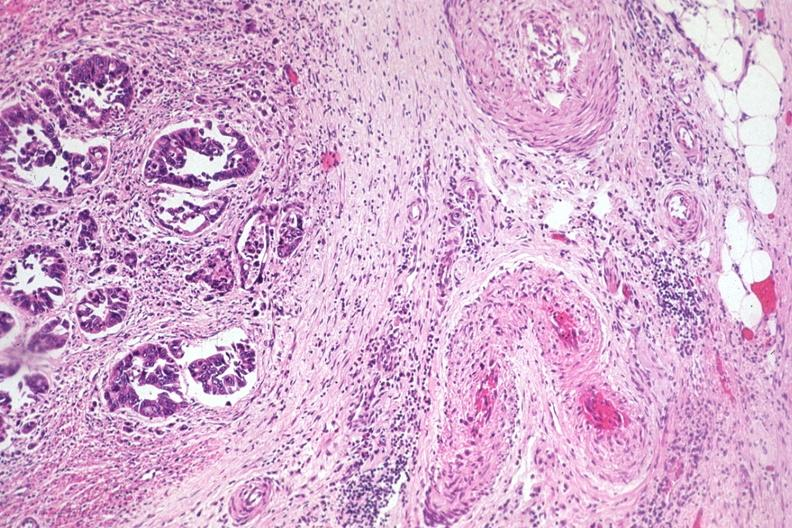s previous slide from this case present?
Answer the question using a single word or phrase. No 